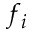Convert formula to latex. <formula><loc_0><loc_0><loc_500><loc_500>f _ { i }</formula> 